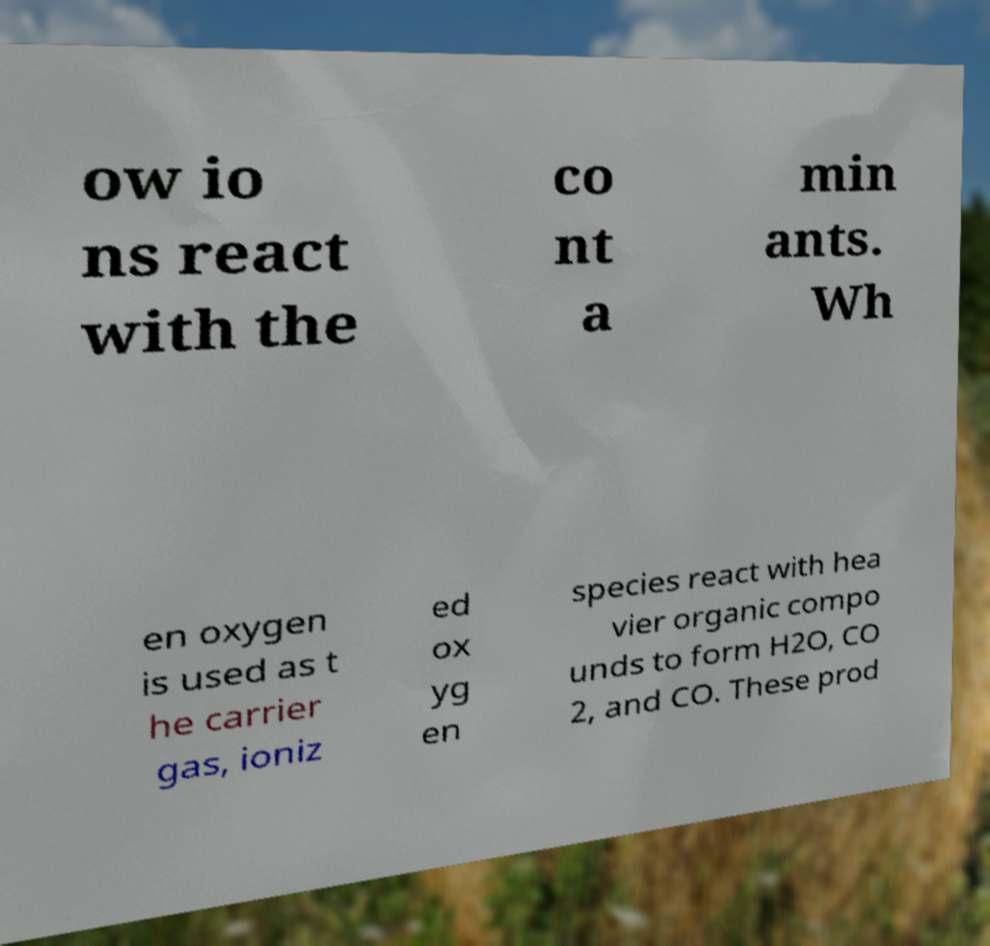I need the written content from this picture converted into text. Can you do that? ow io ns react with the co nt a min ants. Wh en oxygen is used as t he carrier gas, ioniz ed ox yg en species react with hea vier organic compo unds to form H2O, CO 2, and CO. These prod 